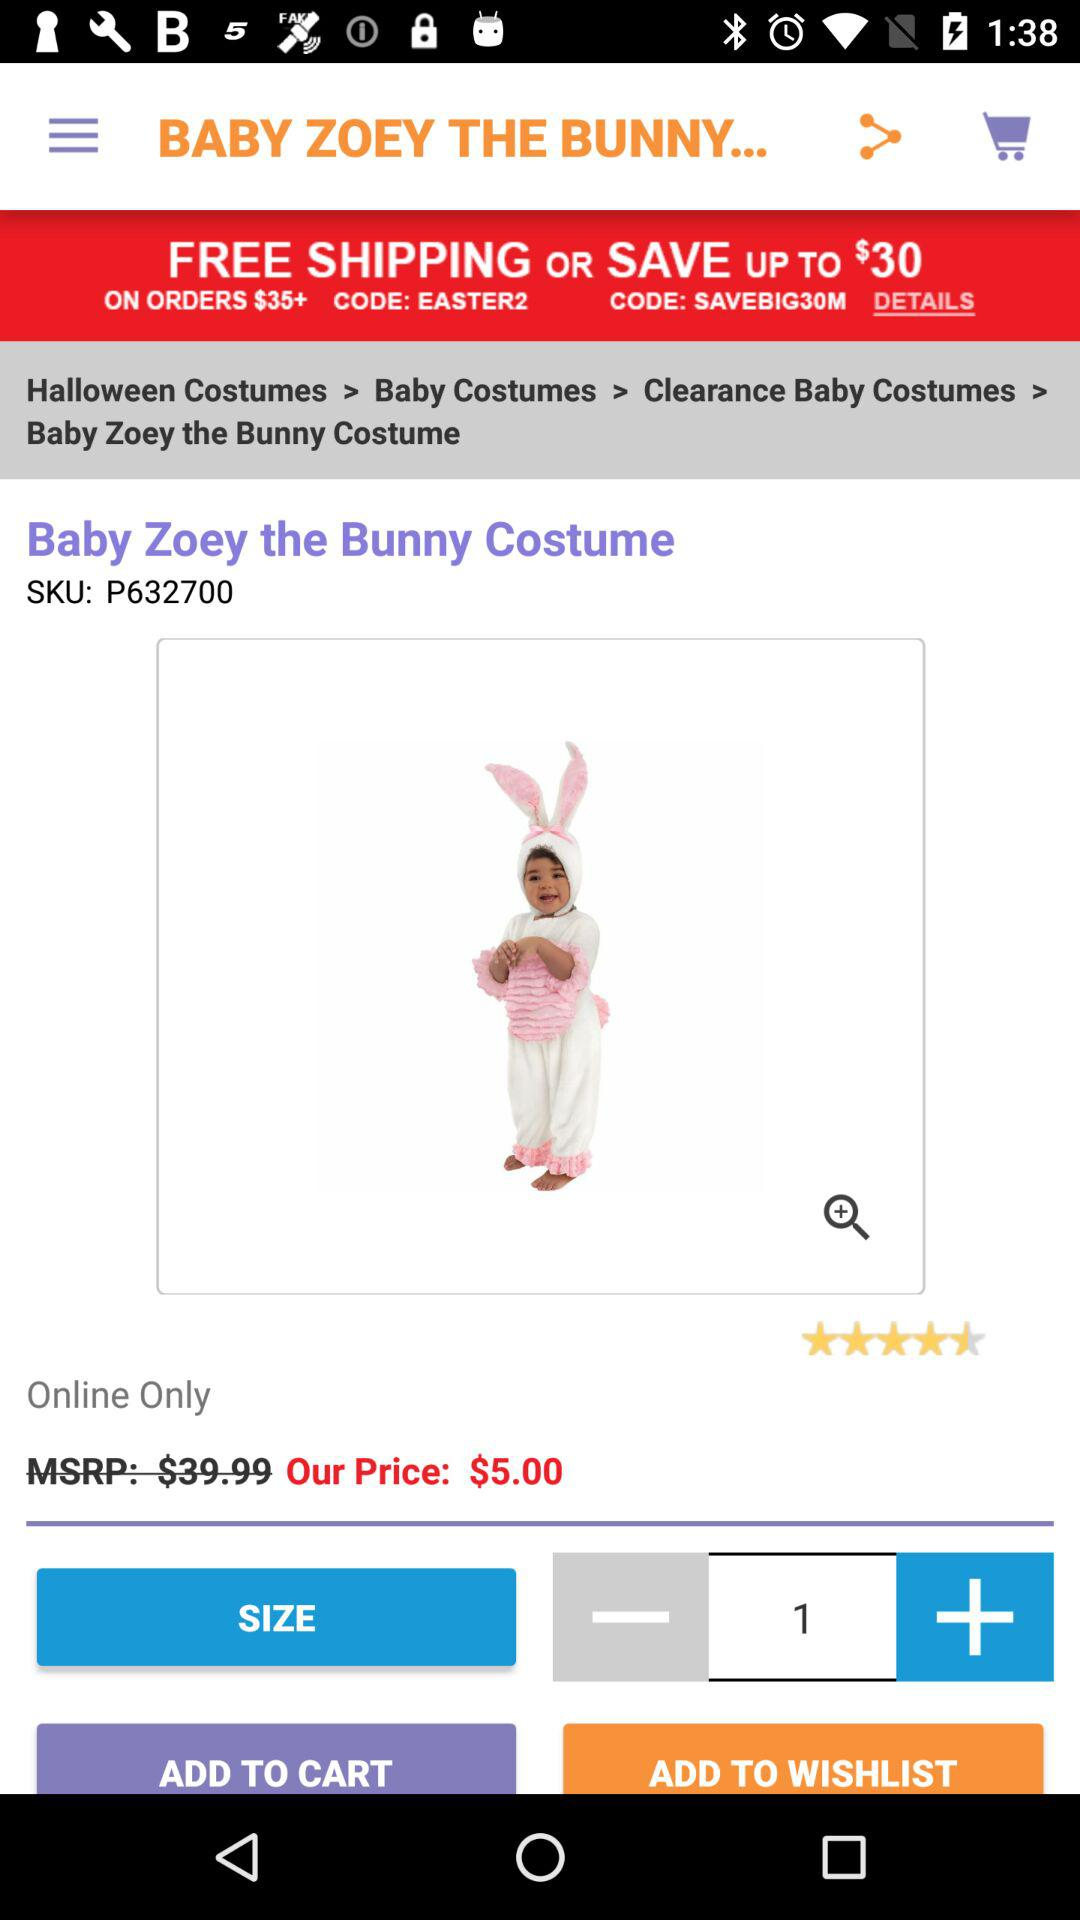What is the code for saving up to $30? The code for saving up to $30 is "SAVEBIG30M". 